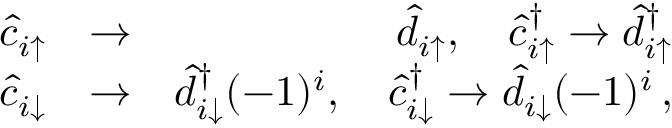<formula> <loc_0><loc_0><loc_500><loc_500>\begin{array} { r l r } { \hat { c } _ { i \uparrow } } & { \rightarrow } & { \hat { d } _ { i \uparrow } , \quad \hat { c } _ { i \uparrow } ^ { \dagger } \rightarrow \hat { d } _ { i \uparrow } ^ { \dagger } } \\ { \hat { c } _ { i \downarrow } } & { \rightarrow } & { \hat { d } _ { i \downarrow } ^ { \dagger } ( - 1 ) ^ { i } , \quad \hat { c } _ { i \downarrow } ^ { \dagger } \rightarrow \hat { d } _ { i \downarrow } ( - 1 ) ^ { i } \, , } \end{array}</formula> 